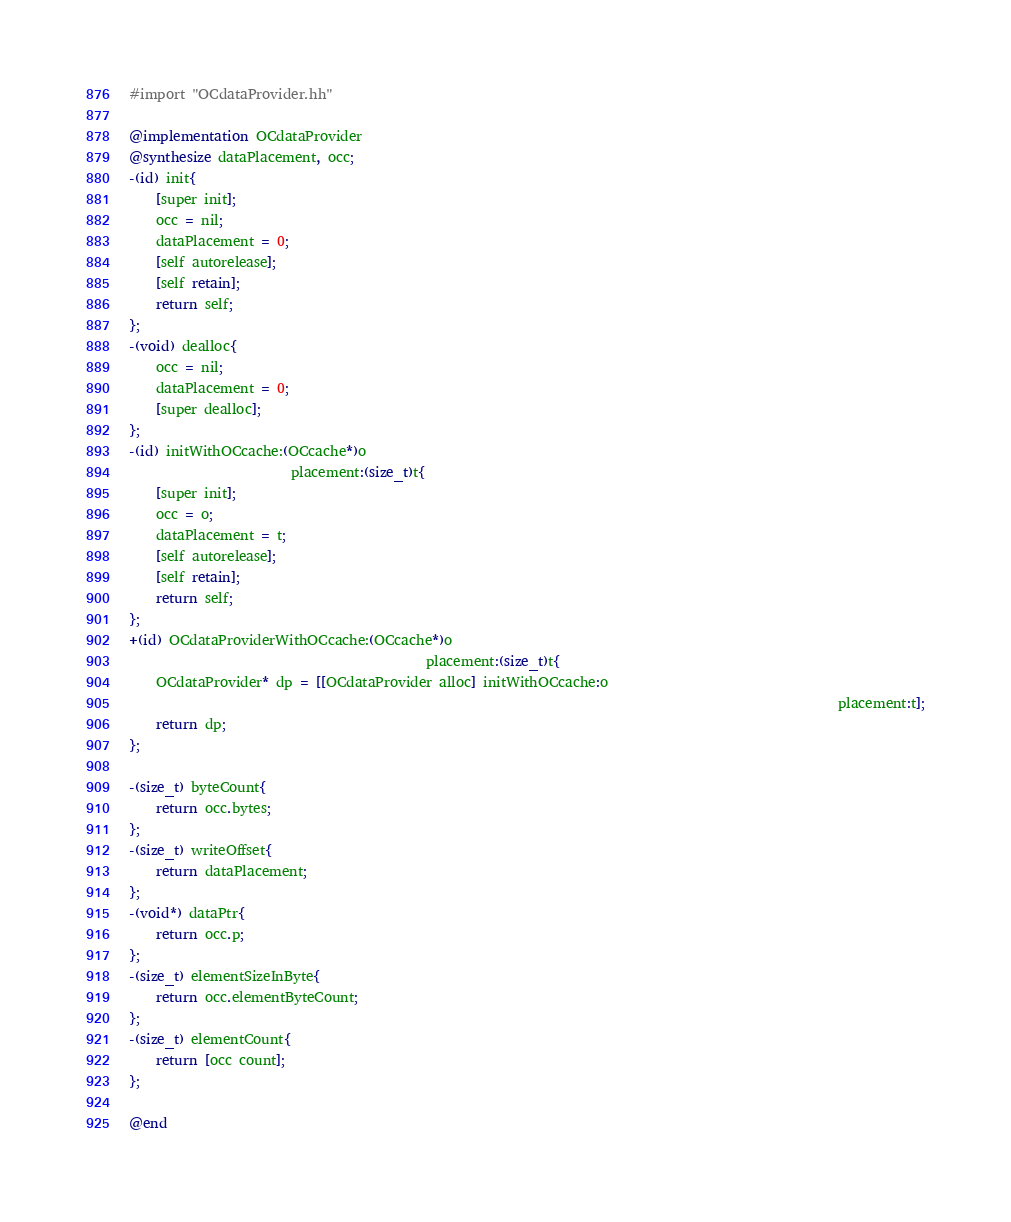Convert code to text. <code><loc_0><loc_0><loc_500><loc_500><_ObjectiveC_>#import "OCdataProvider.hh"

@implementation OCdataProvider
@synthesize dataPlacement, occ;
-(id) init{
	[super init];
	occ = nil;
	dataPlacement = 0;
	[self autorelease];
	[self retain];
	return self;
};
-(void) dealloc{
	occ = nil;
	dataPlacement = 0;
	[super dealloc];
};
-(id) initWithOCcache:(OCcache*)o
						placement:(size_t)t{
	[super init];
	occ = o;
	dataPlacement = t;
	[self autorelease];
	[self retain];
	return self;
};
+(id) OCdataProviderWithOCcache:(OCcache*)o
											placement:(size_t)t{
	OCdataProvider* dp = [[OCdataProvider alloc] initWithOCcache:o
																										 placement:t];
	return dp;
};

-(size_t) byteCount{
	return occ.bytes;
};
-(size_t) writeOffset{
	return dataPlacement;
};
-(void*) dataPtr{
	return occ.p;
};
-(size_t) elementSizeInByte{
	return occ.elementByteCount;
};
-(size_t) elementCount{
	return [occ count];
};

@end
</code> 